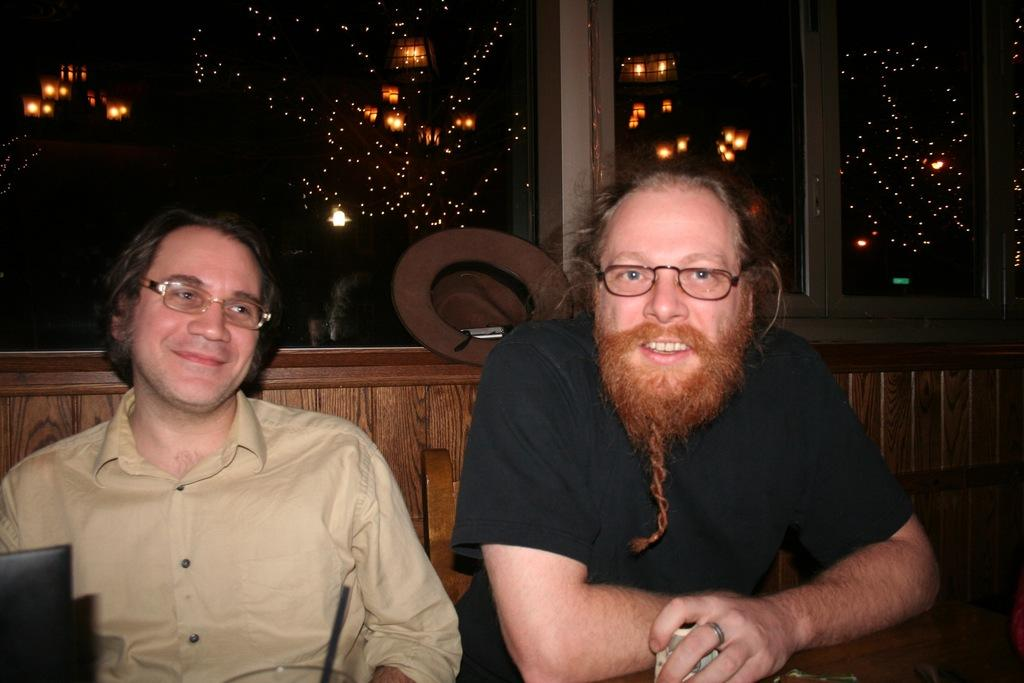How many people are in the image? There are two persons in the image. What can be seen on the wall in the image? There is a glass on the wall in the image. What effect does the glass have in the image? The glass reflects lights in the image. What type of books can be seen on the wall in the image? There are no books present in the image; it features a glass on the wall. How does the hose help the two persons in the image? There is no hose present in the image, so it cannot help the two persons. 